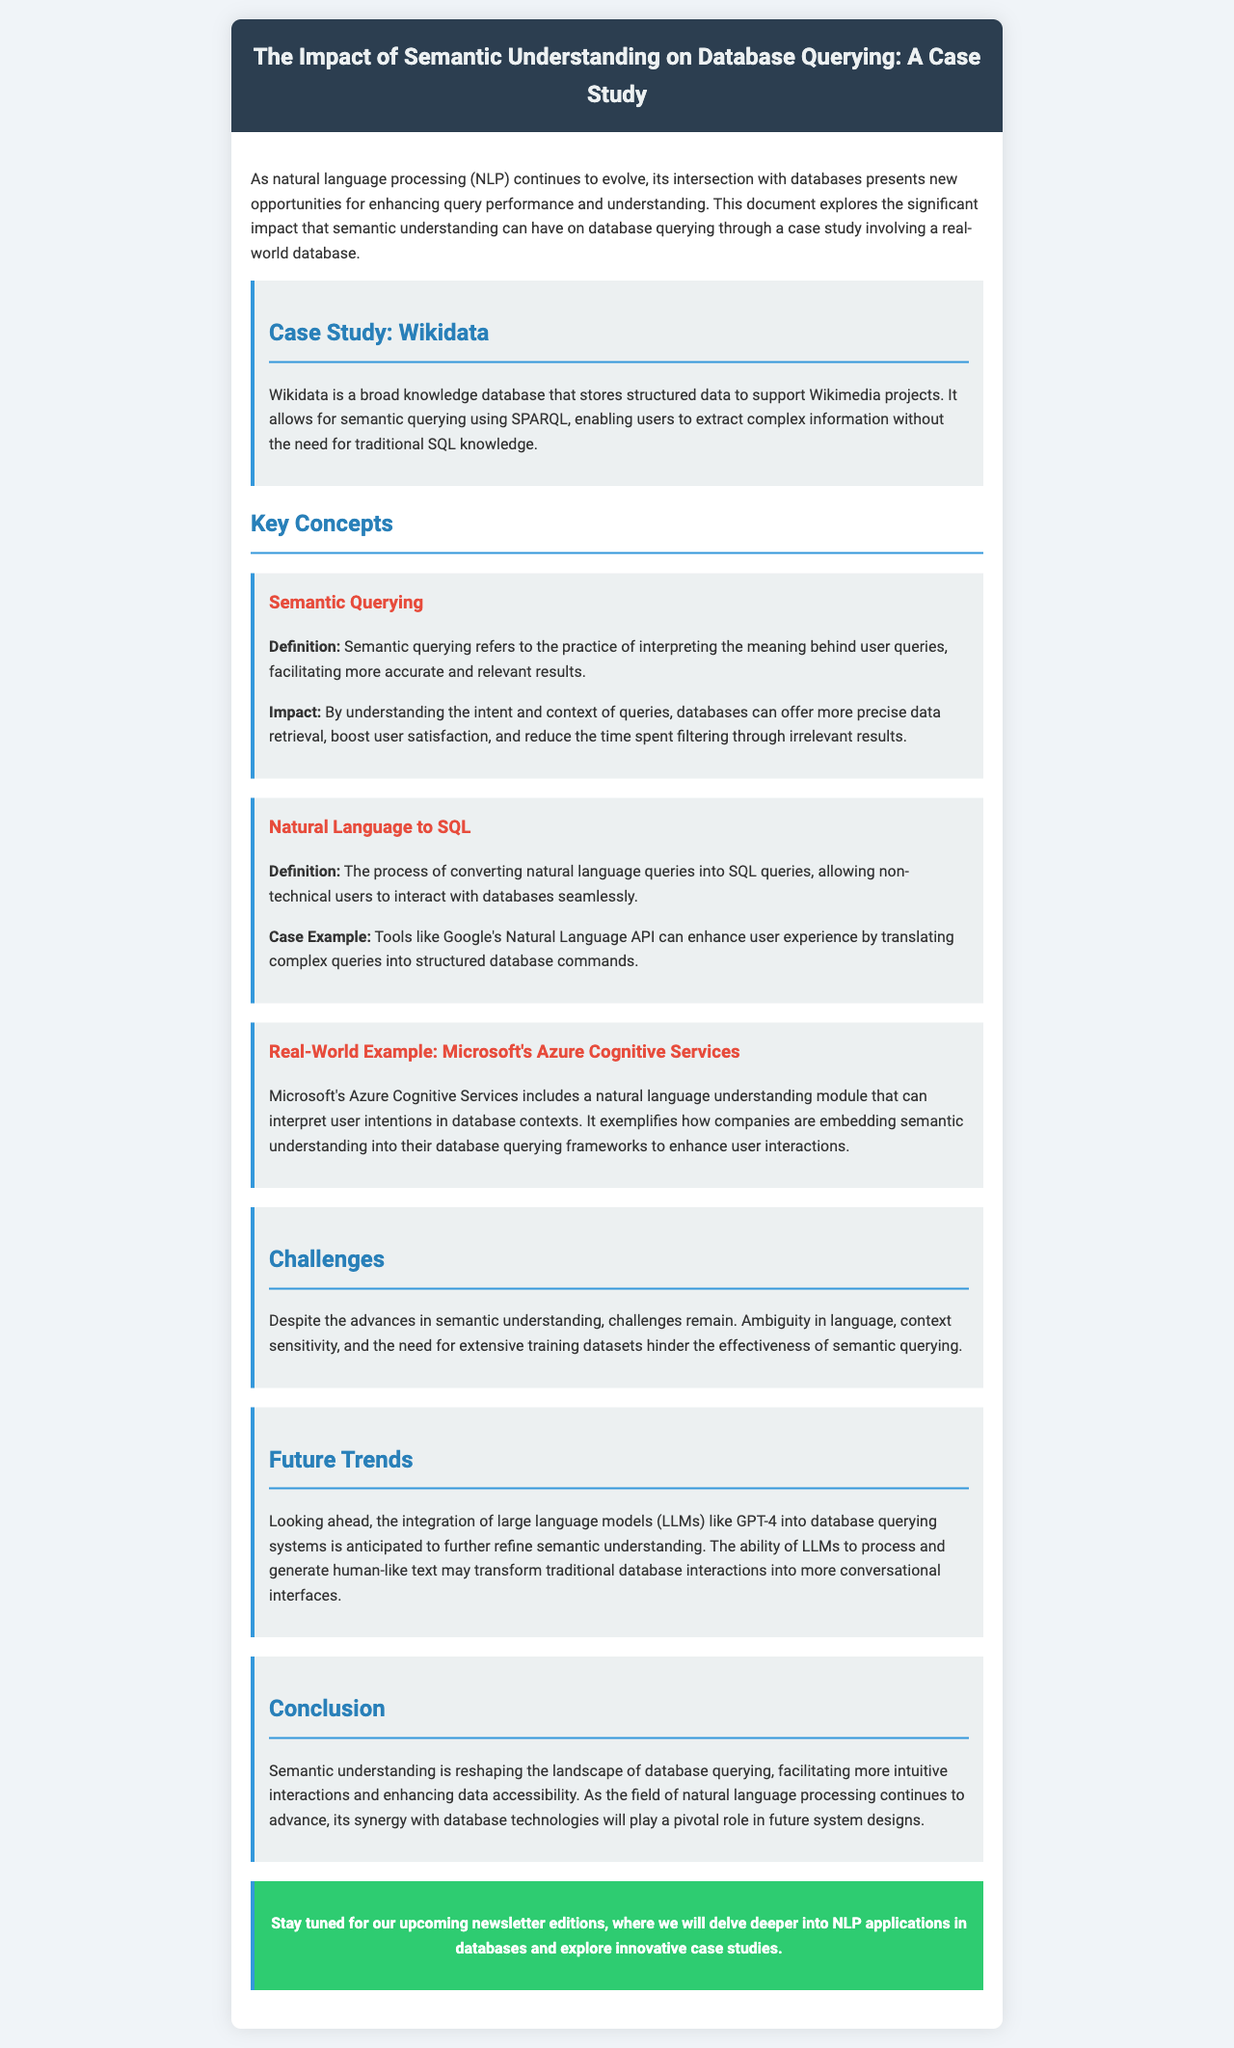What is the title of the newsletter? The title of the newsletter is provided in the header section of the document.
Answer: The Impact of Semantic Understanding on Database Querying: A Case Study What database is featured in the case study? The case study discusses a specific database within the context of the document.
Answer: Wikidata What API is mentioned as enhancing user experience? The document references a specific API that assists in translating natural language into SQL queries.
Answer: Google's Natural Language API What module does Microsoft's Azure Cognitive Services include? The document describes a particular feature of Microsoft's service related to natural language understanding.
Answer: Natural language understanding module What is one main challenge mentioned in the document? The document lists challenges regarding semantic understanding that affect query performance.
Answer: Ambiguity in language Which language model is anticipated to refine semantic understanding? The document predicts the integration of a specific type of model in the future trends section.
Answer: GPT-4 What is the predicted future trend regarding database interactions? The future trends section discusses how interactions with databases may evolve.
Answer: More conversational interfaces How does semantic querying impact query performance? The document explains the significance of semantic understanding for query results.
Answer: Facilitating more accurate and relevant results 